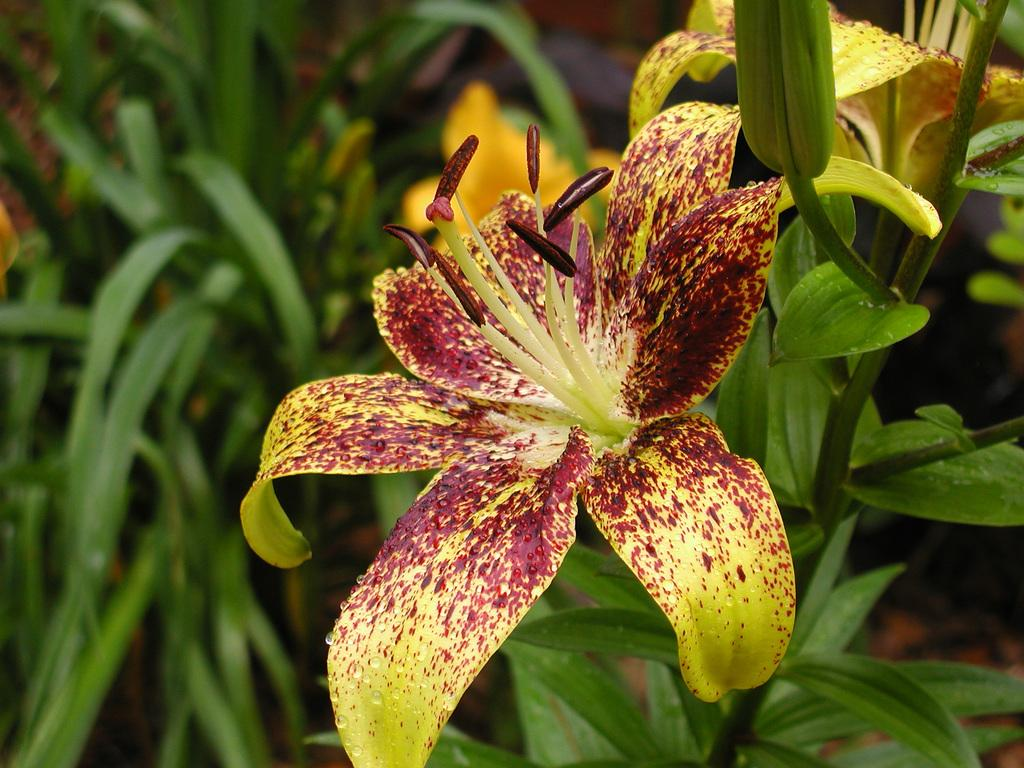What is present in the image? There is a plant in the image. What can be observed about the plant? The plant has flowers. How many cattle are grazing next to the plant in the image? There are no cattle present in the image; it only features a plant with flowers. Is there a notebook lying on the ground near the plant? There is no notebook present in the image; it only features a plant with flowers. 